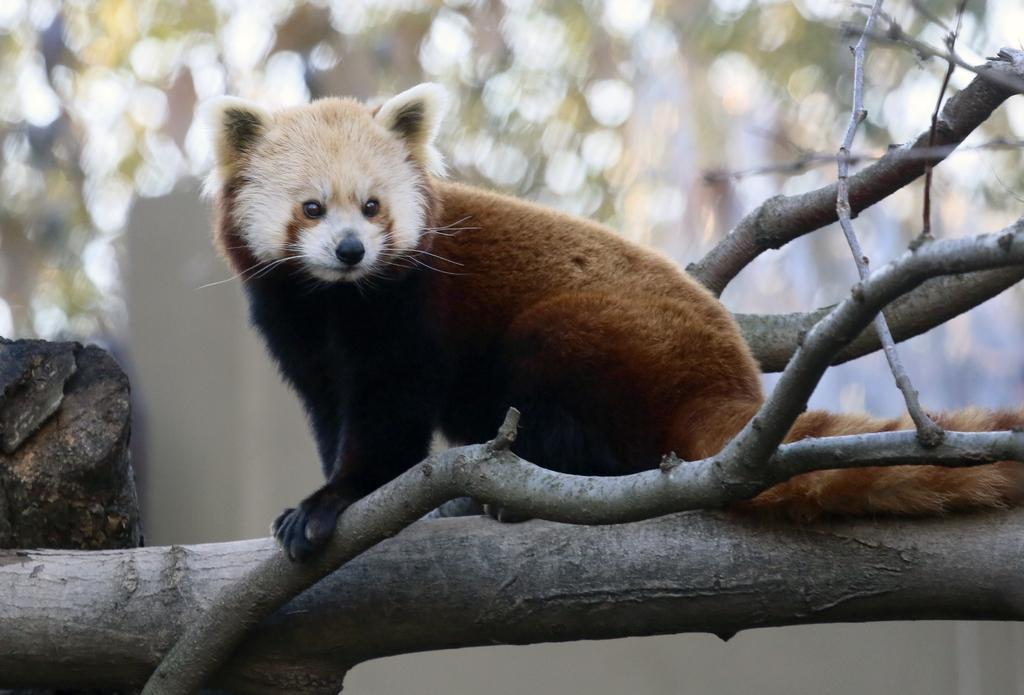What type of creature can be seen in the image? There is an animal in the picture. What colors does the animal have? The animal is in white and brown colors. Where is the animal located in the image? The animal is on a tree branch. How would you describe the background of the image? The background of the image is blurry. How does the animal grip the tree branch with its body? The image does not show the animal gripping the tree branch with its body, as it only depicts the animal sitting on the branch. 